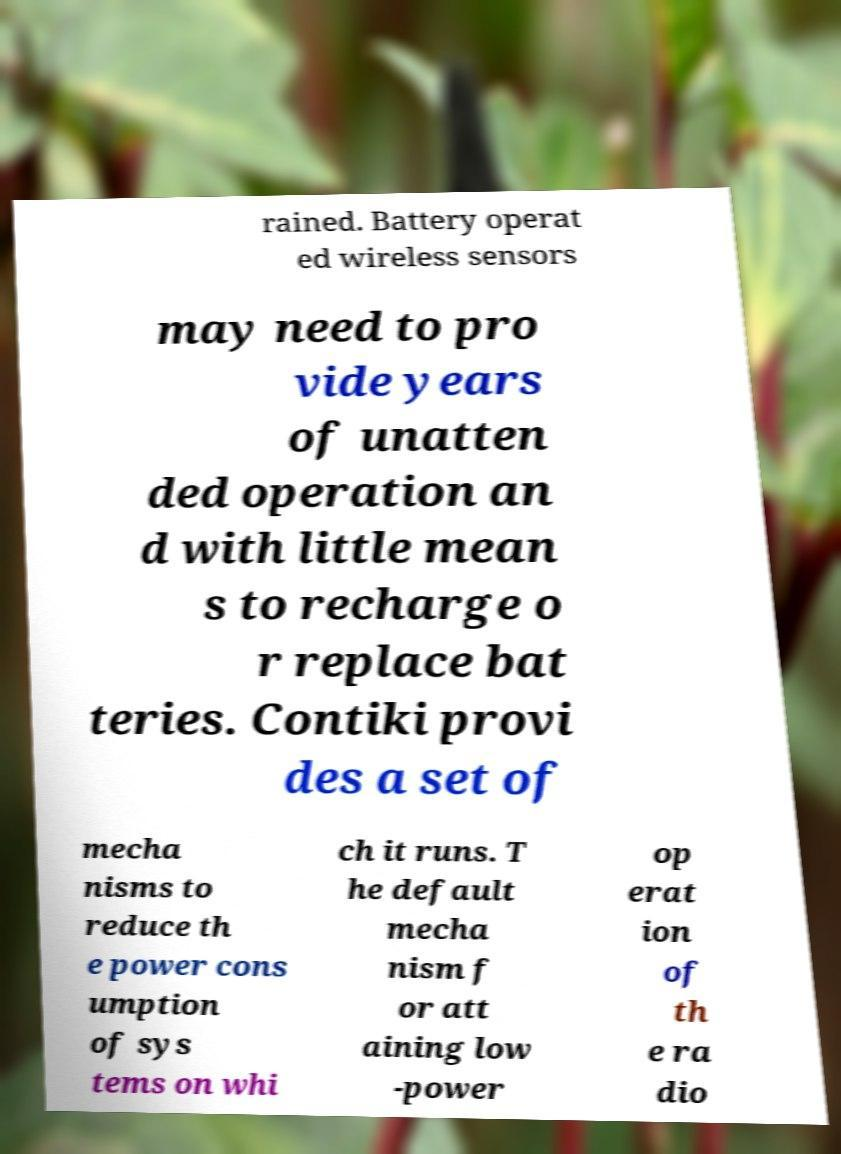Can you accurately transcribe the text from the provided image for me? rained. Battery operat ed wireless sensors may need to pro vide years of unatten ded operation an d with little mean s to recharge o r replace bat teries. Contiki provi des a set of mecha nisms to reduce th e power cons umption of sys tems on whi ch it runs. T he default mecha nism f or att aining low -power op erat ion of th e ra dio 